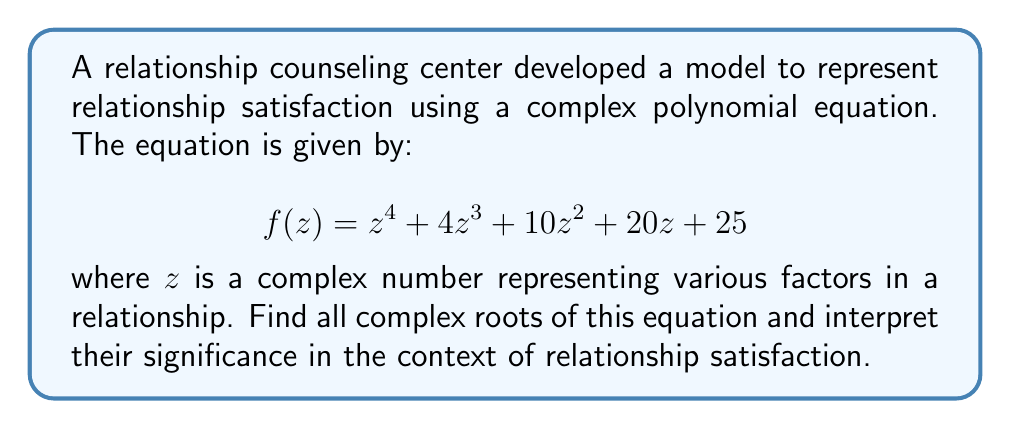Show me your answer to this math problem. To find the complex roots of this polynomial equation, we'll follow these steps:

1) First, observe that the equation can be factored as:

   $$f(z) = (z^2 + 2z + 5)^2$$

2) This means we need to solve the quadratic equation:

   $$z^2 + 2z + 5 = 0$$

3) We can solve this using the quadratic formula: $z = \frac{-b \pm \sqrt{b^2 - 4ac}}{2a}$

   Here, $a=1$, $b=2$, and $c=5$

4) Substituting into the formula:

   $$z = \frac{-2 \pm \sqrt{2^2 - 4(1)(5)}}{2(1)} = \frac{-2 \pm \sqrt{4 - 20}}{2} = \frac{-2 \pm \sqrt{-16}}{2}$$

5) Simplify:

   $$z = \frac{-2 \pm 4i}{2} = -1 \pm 2i$$

6) Therefore, the two complex roots are:

   $$z_1 = -1 + 2i \text{ and } z_2 = -1 - 2i$$

7) Since the original polynomial is $(z^2 + 2z + 5)^2$, each of these roots appears twice.

Interpretation: In the context of relationship satisfaction, the complex roots suggest:

- The real part (-1) could represent a slight negative bias or challenge in the relationship.
- The imaginary part (±2i) could represent the complexity and multifaceted nature of relationships.
- The fact that the roots come in conjugate pairs might indicate the balance and reciprocity needed in a healthy relationship.
- The repetition of roots (each appears twice) could symbolize the reinforcement of patterns in relationships.
Answer: $z = -1 \pm 2i$ (each repeated twice) 